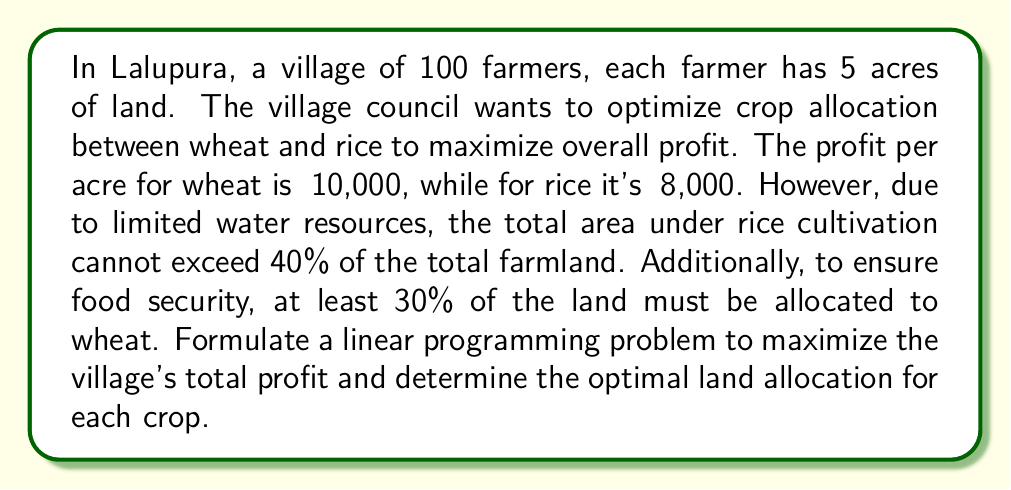Teach me how to tackle this problem. Let's approach this step-by-step:

1) Define variables:
   Let $x$ = acres allocated to wheat
   Let $y$ = acres allocated to rice

2) Objective function:
   Maximize profit = ₹10,000x + ₹8,000y

3) Constraints:
   a) Total land constraint: $x + y = 500$ (100 farmers * 5 acres each)
   b) Rice cultivation limit: $y \leq 0.4(500) = 200$
   c) Wheat cultivation minimum: $x \geq 0.3(500) = 150$
   d) Non-negativity: $x \geq 0, y \geq 0$

4) Linear Programming Problem:
   Maximize $Z = 10000x + 8000y$
   Subject to:
   $x + y = 500$
   $y \leq 200$
   $x \geq 150$
   $x \geq 0, y \geq 0$

5) Solving graphically:
   Plot the constraints:

   [asy]
   import graph;
   size(200);
   xaxis("Wheat (acres)", 0, 550, Arrow);
   yaxis("Rice (acres)", 0, 250, Arrow);
   draw((0,500)--(500,0), blue);
   draw((0,200)--(500,200), red);
   draw((150,0)--(150,350), green);
   label("x + y = 500", (250,250), blue);
   label("y = 200", (250,210), red);
   label("x = 150", (160,100), green);
   fill((150,200)--(300,200)--(150,350)--cycle, palegreen+opacity(0.2));
   dot((300,200));
   label("(300,200)", (310,210), E);
   [/asy]

6) The feasible region is the shaded area. The optimal solution will be at one of the corner points. Evaluating the objective function at each point:
   At (150, 200): Z = 10000(150) + 8000(200) = 3,100,000
   At (300, 200): Z = 10000(300) + 8000(200) = 4,600,000
   At (150, 350): Z = 10000(150) + 8000(350) = 4,300,000

7) The maximum profit is achieved at the point (300, 200).

Therefore, the optimal allocation is 300 acres for wheat and 200 acres for rice.
Answer: The optimal land allocation to maximize profit is 300 acres for wheat and 200 acres for rice, resulting in a total profit of ₹4,600,000 for the village. 